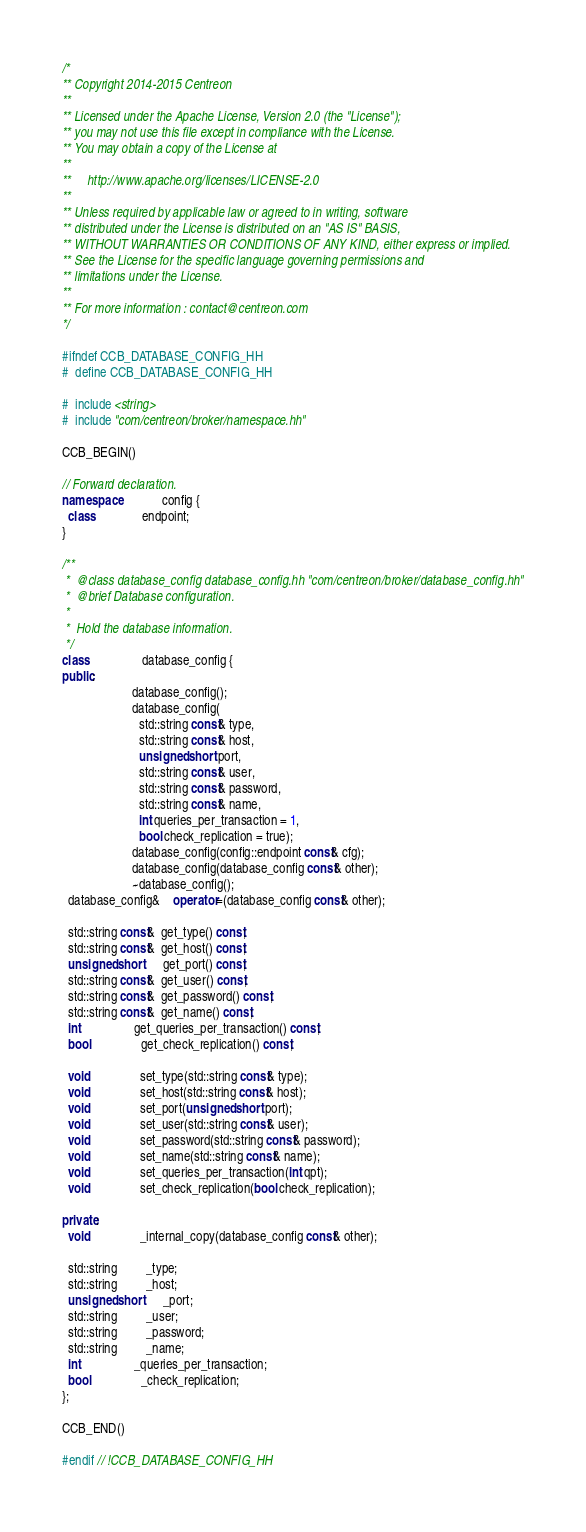Convert code to text. <code><loc_0><loc_0><loc_500><loc_500><_C++_>/*
** Copyright 2014-2015 Centreon
**
** Licensed under the Apache License, Version 2.0 (the "License");
** you may not use this file except in compliance with the License.
** You may obtain a copy of the License at
**
**     http://www.apache.org/licenses/LICENSE-2.0
**
** Unless required by applicable law or agreed to in writing, software
** distributed under the License is distributed on an "AS IS" BASIS,
** WITHOUT WARRANTIES OR CONDITIONS OF ANY KIND, either express or implied.
** See the License for the specific language governing permissions and
** limitations under the License.
**
** For more information : contact@centreon.com
*/

#ifndef CCB_DATABASE_CONFIG_HH
#  define CCB_DATABASE_CONFIG_HH

#  include <string>
#  include "com/centreon/broker/namespace.hh"

CCB_BEGIN()

// Forward declaration.
namespace             config {
  class               endpoint;
}

/**
 *  @class database_config database_config.hh "com/centreon/broker/database_config.hh"
 *  @brief Database configuration.
 *
 *  Hold the database information.
 */
class                 database_config {
public:
                      database_config();
                      database_config(
                        std::string const& type,
                        std::string const& host,
                        unsigned short port,
                        std::string const& user,
                        std::string const& password,
                        std::string const& name,
                        int queries_per_transaction = 1,
                        bool check_replication = true);
                      database_config(config::endpoint const& cfg);
                      database_config(database_config const& other);
                      ~database_config();
  database_config&    operator=(database_config const& other);

  std::string const&  get_type() const;
  std::string const&  get_host() const;
  unsigned short      get_port() const;
  std::string const&  get_user() const;
  std::string const&  get_password() const;
  std::string const&  get_name() const;
  int                 get_queries_per_transaction() const;
  bool                get_check_replication() const;

  void                set_type(std::string const& type);
  void                set_host(std::string const& host);
  void                set_port(unsigned short port);
  void                set_user(std::string const& user);
  void                set_password(std::string const& password);
  void                set_name(std::string const& name);
  void                set_queries_per_transaction(int qpt);
  void                set_check_replication(bool check_replication);

private:
  void                _internal_copy(database_config const& other);

  std::string         _type;
  std::string         _host;
  unsigned short      _port;
  std::string         _user;
  std::string         _password;
  std::string         _name;
  int                 _queries_per_transaction;
  bool                _check_replication;
};

CCB_END()

#endif // !CCB_DATABASE_CONFIG_HH
</code> 